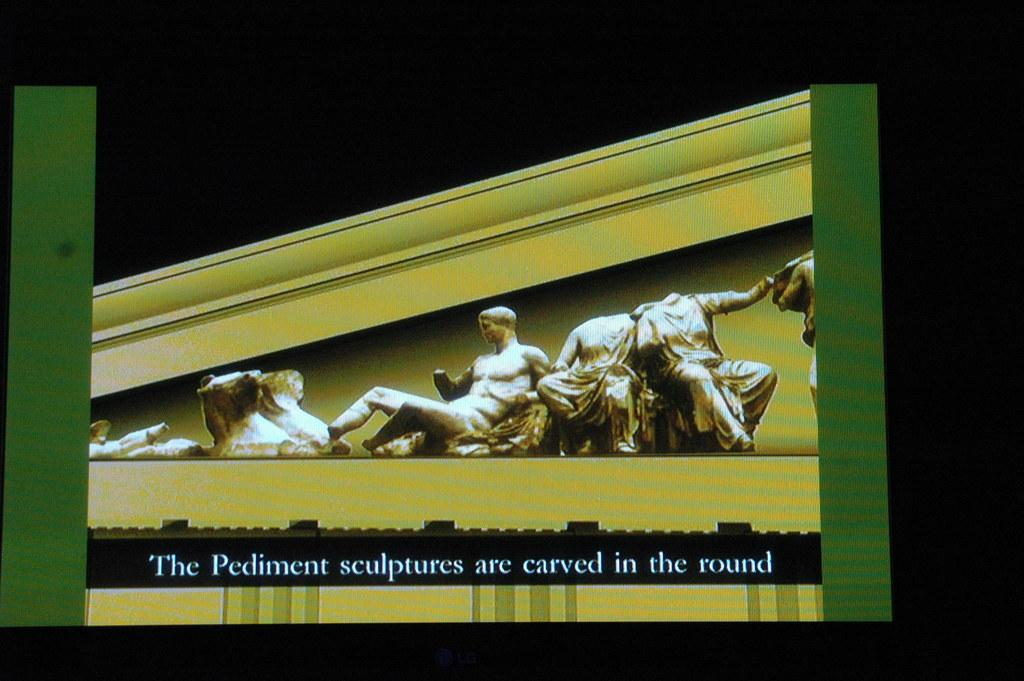What is the main object in the image? There is a screen in the image. What can be seen on the screen? Text is present on the screen, and there is an image of sculptures. What type of card is being used to create the sculptures in the image? There is no card present in the image, and the sculptures are not being created in the image. The image only shows an image of sculptures on the screen. 